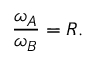<formula> <loc_0><loc_0><loc_500><loc_500>{ \frac { \omega _ { A } } { \omega _ { B } } } = R .</formula> 